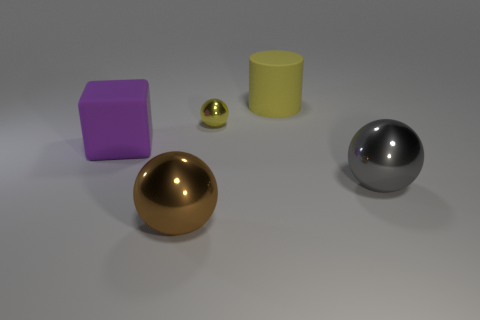Add 2 big yellow matte objects. How many objects exist? 7 Subtract all cubes. How many objects are left? 4 Add 2 yellow rubber objects. How many yellow rubber objects exist? 3 Subtract 0 red balls. How many objects are left? 5 Subtract all tiny yellow metal objects. Subtract all tiny yellow things. How many objects are left? 3 Add 5 large rubber cylinders. How many large rubber cylinders are left? 6 